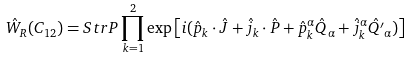Convert formula to latex. <formula><loc_0><loc_0><loc_500><loc_500>\hat { W } _ { R } ( C _ { 1 2 } ) = S t r P \prod _ { k = 1 } ^ { 2 } \exp \left [ i ( \hat { p } _ { k } \cdot \hat { J } + \hat { j } _ { k } \cdot \hat { P } + \hat { p } ^ { \alpha } _ { k } \hat { Q } _ { \alpha } + \hat { j } ^ { \alpha } _ { k } \hat { Q ^ { \prime } } _ { \alpha } ) \right ]</formula> 